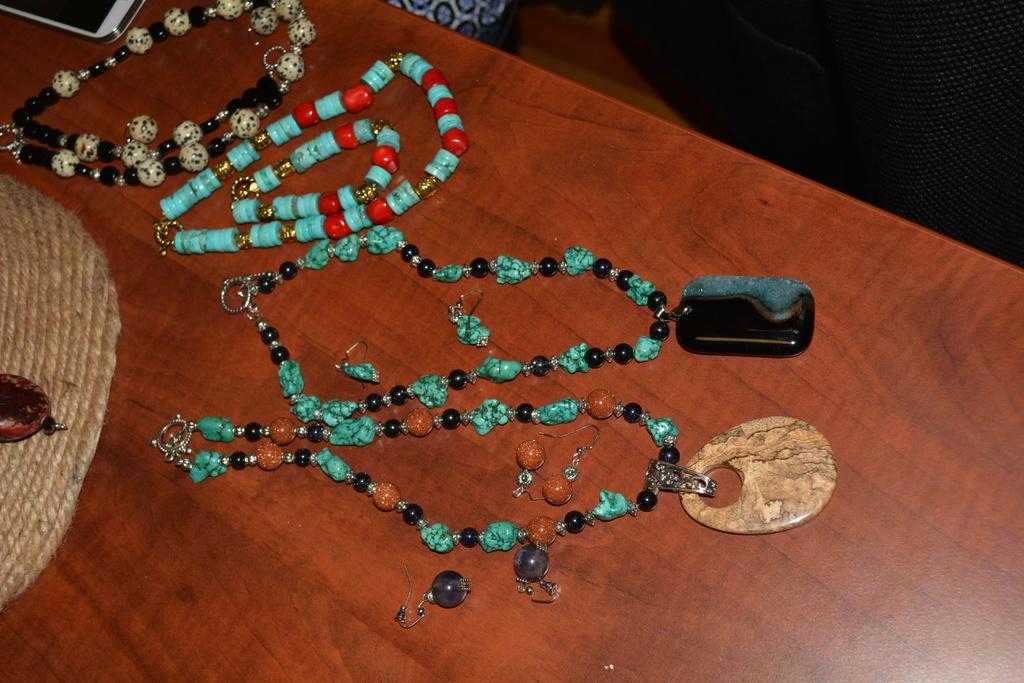Describe this image in one or two sentences. There are bead chains arranged on a wooden table, on which there is an object. And the background is dark in color. 